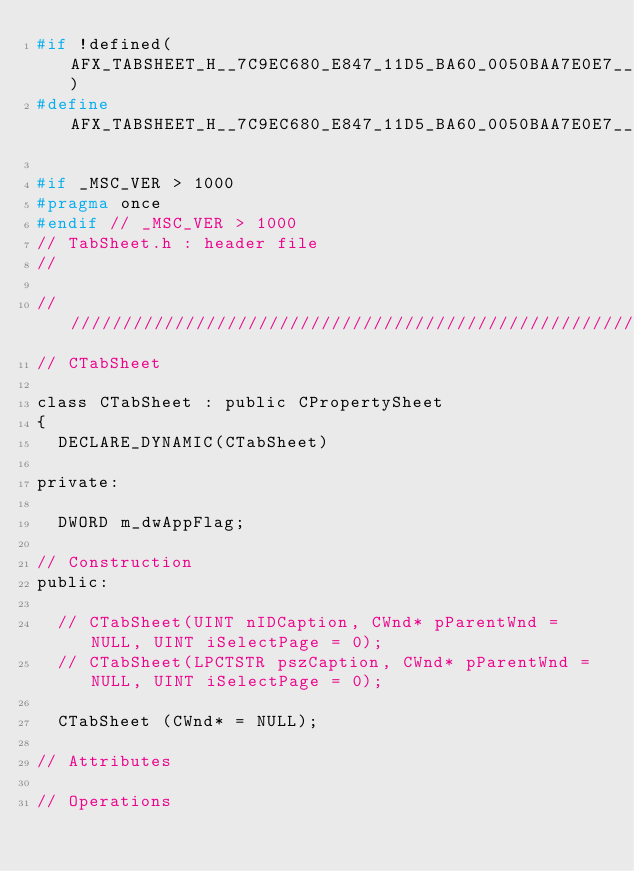<code> <loc_0><loc_0><loc_500><loc_500><_C_>#if !defined(AFX_TABSHEET_H__7C9EC680_E847_11D5_BA60_0050BAA7E0E7__INCLUDED_)
#define AFX_TABSHEET_H__7C9EC680_E847_11D5_BA60_0050BAA7E0E7__INCLUDED_

#if _MSC_VER > 1000
#pragma once
#endif // _MSC_VER > 1000
// TabSheet.h : header file
//

/////////////////////////////////////////////////////////////////////////////
// CTabSheet

class CTabSheet : public CPropertySheet
{
	DECLARE_DYNAMIC(CTabSheet)

private:

	DWORD m_dwAppFlag;

// Construction
public:

	// CTabSheet(UINT nIDCaption, CWnd* pParentWnd = NULL, UINT iSelectPage = 0);
	// CTabSheet(LPCTSTR pszCaption, CWnd* pParentWnd = NULL, UINT iSelectPage = 0);

	CTabSheet (CWnd* = NULL);

// Attributes

// Operations
</code> 